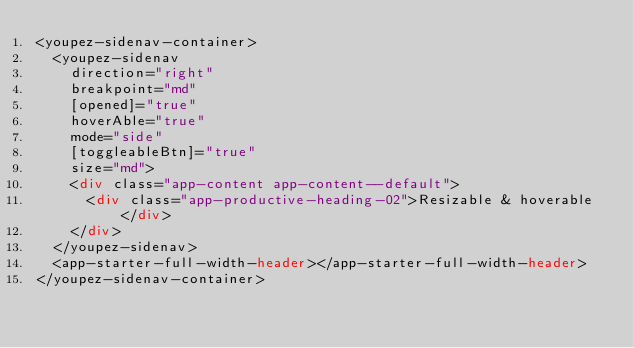<code> <loc_0><loc_0><loc_500><loc_500><_HTML_><youpez-sidenav-container>
  <youpez-sidenav
    direction="right"
    breakpoint="md"
    [opened]="true"
    hoverAble="true"
    mode="side"
    [toggleableBtn]="true"
    size="md">
    <div class="app-content app-content--default">
      <div class="app-productive-heading-02">Resizable & hoverable</div>
    </div>
  </youpez-sidenav>
  <app-starter-full-width-header></app-starter-full-width-header>
</youpez-sidenav-container>
</code> 